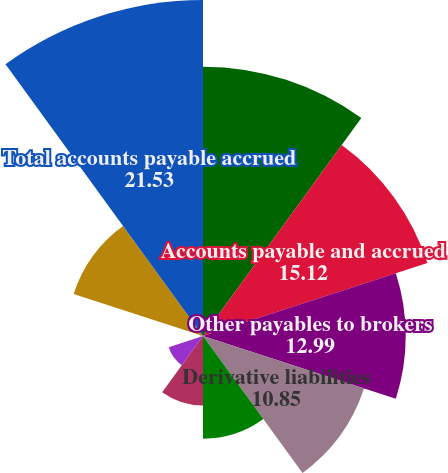<chart> <loc_0><loc_0><loc_500><loc_500><pie_chart><fcel>Deposits received for<fcel>Accounts payable and accrued<fcel>Other payables to brokers<fcel>Derivative liabilities<fcel>Subserviced loan advances<fcel>Fails to receive<fcel>Senior and convertible debt<fcel>Facility restructuring and<fcel>Other<fcel>Total accounts payable accrued<nl><fcel>17.26%<fcel>15.12%<fcel>12.99%<fcel>10.85%<fcel>6.58%<fcel>4.45%<fcel>2.31%<fcel>0.18%<fcel>8.72%<fcel>21.53%<nl></chart> 